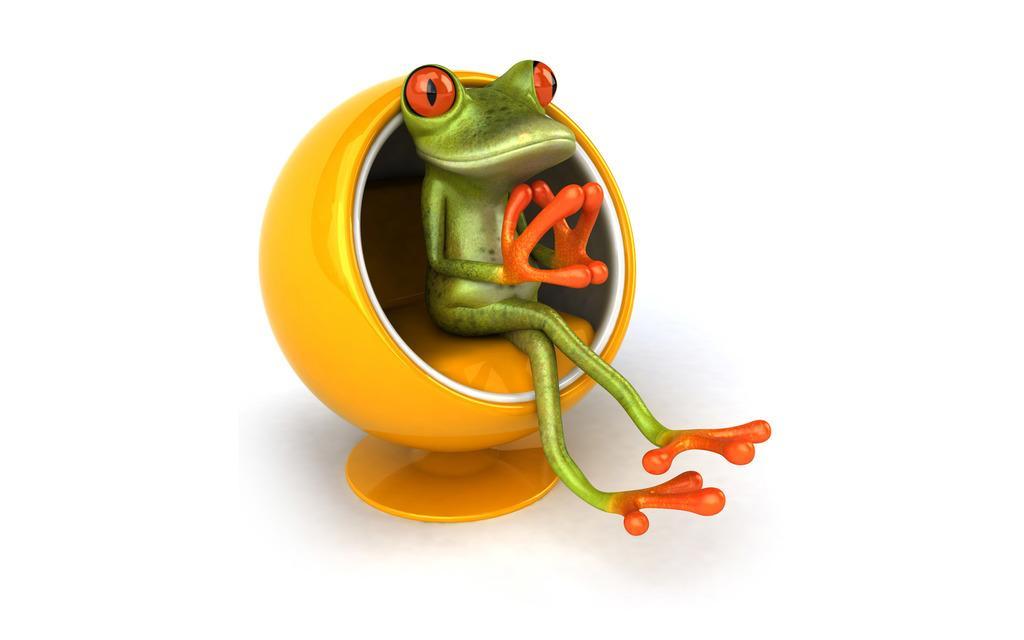How would you summarize this image in a sentence or two? This is an animated image. In the center of the image we can see depiction of a frog sitting on the yellow color chair. 